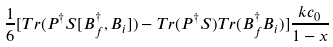<formula> <loc_0><loc_0><loc_500><loc_500>\frac { 1 } { 6 } [ T r ( P ^ { \dagger } S [ B ^ { \dagger } _ { f } , B _ { i } ] ) - T r ( P ^ { \dagger } S ) T r ( B ^ { \dagger } _ { f } B _ { i } ) ] \frac { k c _ { 0 } } { 1 - x }</formula> 